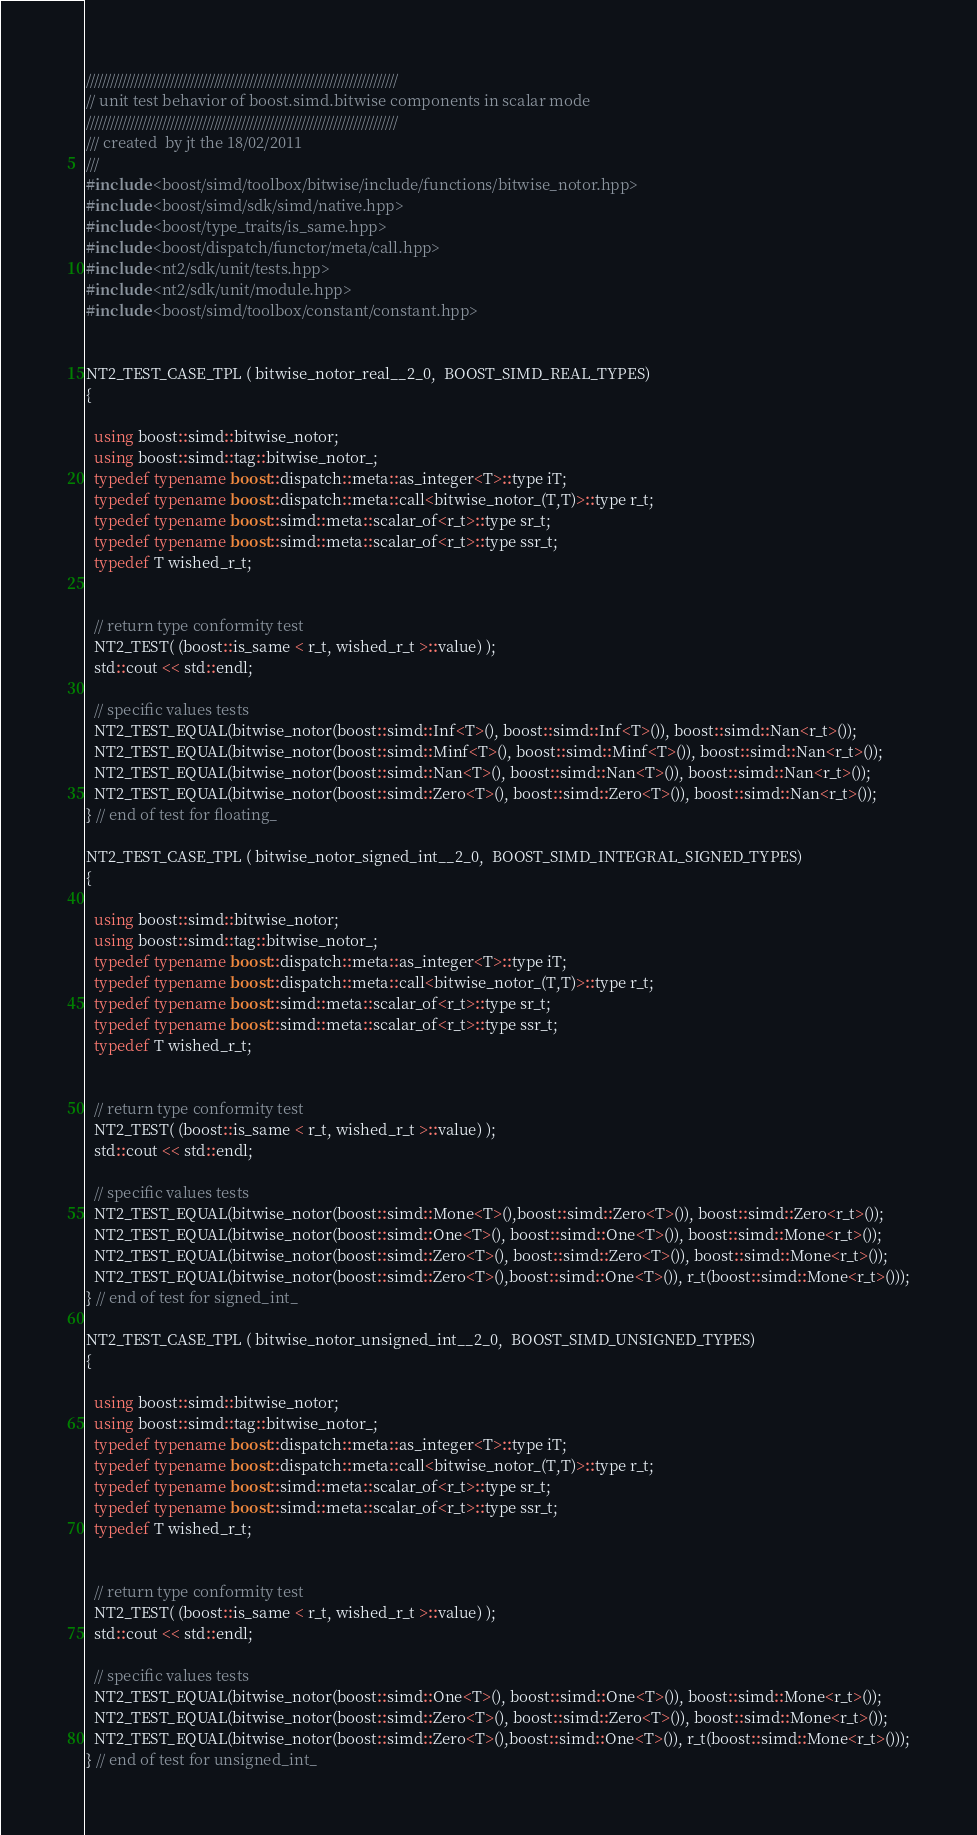<code> <loc_0><loc_0><loc_500><loc_500><_C++_>//////////////////////////////////////////////////////////////////////////////
// unit test behavior of boost.simd.bitwise components in scalar mode
//////////////////////////////////////////////////////////////////////////////
/// created  by jt the 18/02/2011
///
#include <boost/simd/toolbox/bitwise/include/functions/bitwise_notor.hpp>
#include <boost/simd/sdk/simd/native.hpp>
#include <boost/type_traits/is_same.hpp>
#include <boost/dispatch/functor/meta/call.hpp>
#include <nt2/sdk/unit/tests.hpp>
#include <nt2/sdk/unit/module.hpp>
#include <boost/simd/toolbox/constant/constant.hpp>


NT2_TEST_CASE_TPL ( bitwise_notor_real__2_0,  BOOST_SIMD_REAL_TYPES)
{

  using boost::simd::bitwise_notor;
  using boost::simd::tag::bitwise_notor_;
  typedef typename boost::dispatch::meta::as_integer<T>::type iT;
  typedef typename boost::dispatch::meta::call<bitwise_notor_(T,T)>::type r_t;
  typedef typename boost::simd::meta::scalar_of<r_t>::type sr_t;
  typedef typename boost::simd::meta::scalar_of<r_t>::type ssr_t;
  typedef T wished_r_t;


  // return type conformity test
  NT2_TEST( (boost::is_same < r_t, wished_r_t >::value) );
  std::cout << std::endl;

  // specific values tests
  NT2_TEST_EQUAL(bitwise_notor(boost::simd::Inf<T>(), boost::simd::Inf<T>()), boost::simd::Nan<r_t>());
  NT2_TEST_EQUAL(bitwise_notor(boost::simd::Minf<T>(), boost::simd::Minf<T>()), boost::simd::Nan<r_t>());
  NT2_TEST_EQUAL(bitwise_notor(boost::simd::Nan<T>(), boost::simd::Nan<T>()), boost::simd::Nan<r_t>());
  NT2_TEST_EQUAL(bitwise_notor(boost::simd::Zero<T>(), boost::simd::Zero<T>()), boost::simd::Nan<r_t>());
} // end of test for floating_

NT2_TEST_CASE_TPL ( bitwise_notor_signed_int__2_0,  BOOST_SIMD_INTEGRAL_SIGNED_TYPES)
{

  using boost::simd::bitwise_notor;
  using boost::simd::tag::bitwise_notor_;
  typedef typename boost::dispatch::meta::as_integer<T>::type iT;
  typedef typename boost::dispatch::meta::call<bitwise_notor_(T,T)>::type r_t;
  typedef typename boost::simd::meta::scalar_of<r_t>::type sr_t;
  typedef typename boost::simd::meta::scalar_of<r_t>::type ssr_t;
  typedef T wished_r_t;


  // return type conformity test
  NT2_TEST( (boost::is_same < r_t, wished_r_t >::value) );
  std::cout << std::endl;

  // specific values tests
  NT2_TEST_EQUAL(bitwise_notor(boost::simd::Mone<T>(),boost::simd::Zero<T>()), boost::simd::Zero<r_t>());
  NT2_TEST_EQUAL(bitwise_notor(boost::simd::One<T>(), boost::simd::One<T>()), boost::simd::Mone<r_t>());
  NT2_TEST_EQUAL(bitwise_notor(boost::simd::Zero<T>(), boost::simd::Zero<T>()), boost::simd::Mone<r_t>());
  NT2_TEST_EQUAL(bitwise_notor(boost::simd::Zero<T>(),boost::simd::One<T>()), r_t(boost::simd::Mone<r_t>()));
} // end of test for signed_int_

NT2_TEST_CASE_TPL ( bitwise_notor_unsigned_int__2_0,  BOOST_SIMD_UNSIGNED_TYPES)
{

  using boost::simd::bitwise_notor;
  using boost::simd::tag::bitwise_notor_;
  typedef typename boost::dispatch::meta::as_integer<T>::type iT;
  typedef typename boost::dispatch::meta::call<bitwise_notor_(T,T)>::type r_t;
  typedef typename boost::simd::meta::scalar_of<r_t>::type sr_t;
  typedef typename boost::simd::meta::scalar_of<r_t>::type ssr_t;
  typedef T wished_r_t;


  // return type conformity test
  NT2_TEST( (boost::is_same < r_t, wished_r_t >::value) );
  std::cout << std::endl;

  // specific values tests
  NT2_TEST_EQUAL(bitwise_notor(boost::simd::One<T>(), boost::simd::One<T>()), boost::simd::Mone<r_t>());
  NT2_TEST_EQUAL(bitwise_notor(boost::simd::Zero<T>(), boost::simd::Zero<T>()), boost::simd::Mone<r_t>());
  NT2_TEST_EQUAL(bitwise_notor(boost::simd::Zero<T>(),boost::simd::One<T>()), r_t(boost::simd::Mone<r_t>()));
} // end of test for unsigned_int_
</code> 